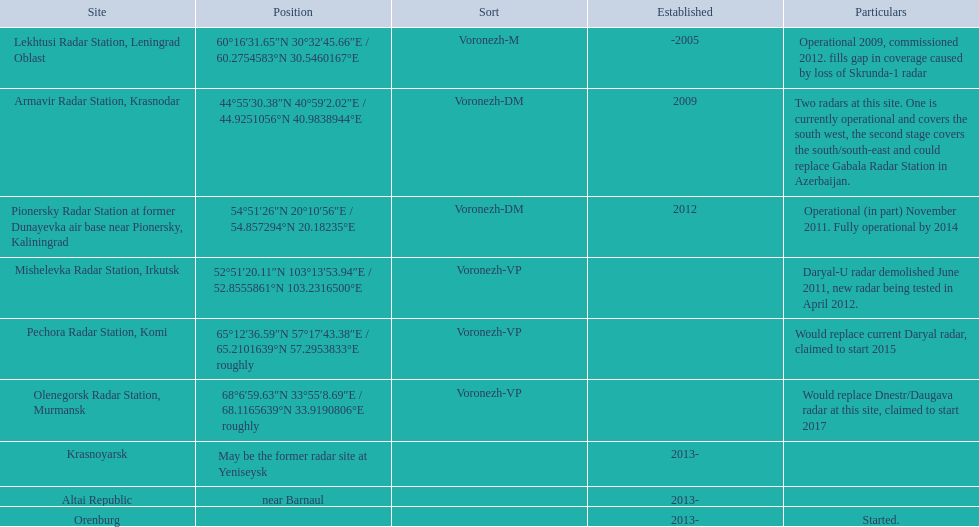Can you give me this table as a dict? {'header': ['Site', 'Position', 'Sort', 'Established', 'Particulars'], 'rows': [['Lekhtusi Radar Station, Leningrad Oblast', '60°16′31.65″N 30°32′45.66″E\ufeff / \ufeff60.2754583°N 30.5460167°E', 'Voronezh-M', '-2005', 'Operational 2009, commissioned 2012. fills gap in coverage caused by loss of Skrunda-1 radar'], ['Armavir Radar Station, Krasnodar', '44°55′30.38″N 40°59′2.02″E\ufeff / \ufeff44.9251056°N 40.9838944°E', 'Voronezh-DM', '2009', 'Two radars at this site. One is currently operational and covers the south west, the second stage covers the south/south-east and could replace Gabala Radar Station in Azerbaijan.'], ['Pionersky Radar Station at former Dunayevka air base near Pionersky, Kaliningrad', '54°51′26″N 20°10′56″E\ufeff / \ufeff54.857294°N 20.18235°E', 'Voronezh-DM', '2012', 'Operational (in part) November 2011. Fully operational by 2014'], ['Mishelevka Radar Station, Irkutsk', '52°51′20.11″N 103°13′53.94″E\ufeff / \ufeff52.8555861°N 103.2316500°E', 'Voronezh-VP', '', 'Daryal-U radar demolished June 2011, new radar being tested in April 2012.'], ['Pechora Radar Station, Komi', '65°12′36.59″N 57°17′43.38″E\ufeff / \ufeff65.2101639°N 57.2953833°E roughly', 'Voronezh-VP', '', 'Would replace current Daryal radar, claimed to start 2015'], ['Olenegorsk Radar Station, Murmansk', '68°6′59.63″N 33°55′8.69″E\ufeff / \ufeff68.1165639°N 33.9190806°E roughly', 'Voronezh-VP', '', 'Would replace Dnestr/Daugava radar at this site, claimed to start 2017'], ['Krasnoyarsk', 'May be the former radar site at Yeniseysk', '', '2013-', ''], ['Altai Republic', 'near Barnaul', '', '2013-', ''], ['Orenburg', '', '', '2013-', 'Started.']]} When was the top created in terms of year? -2005. 